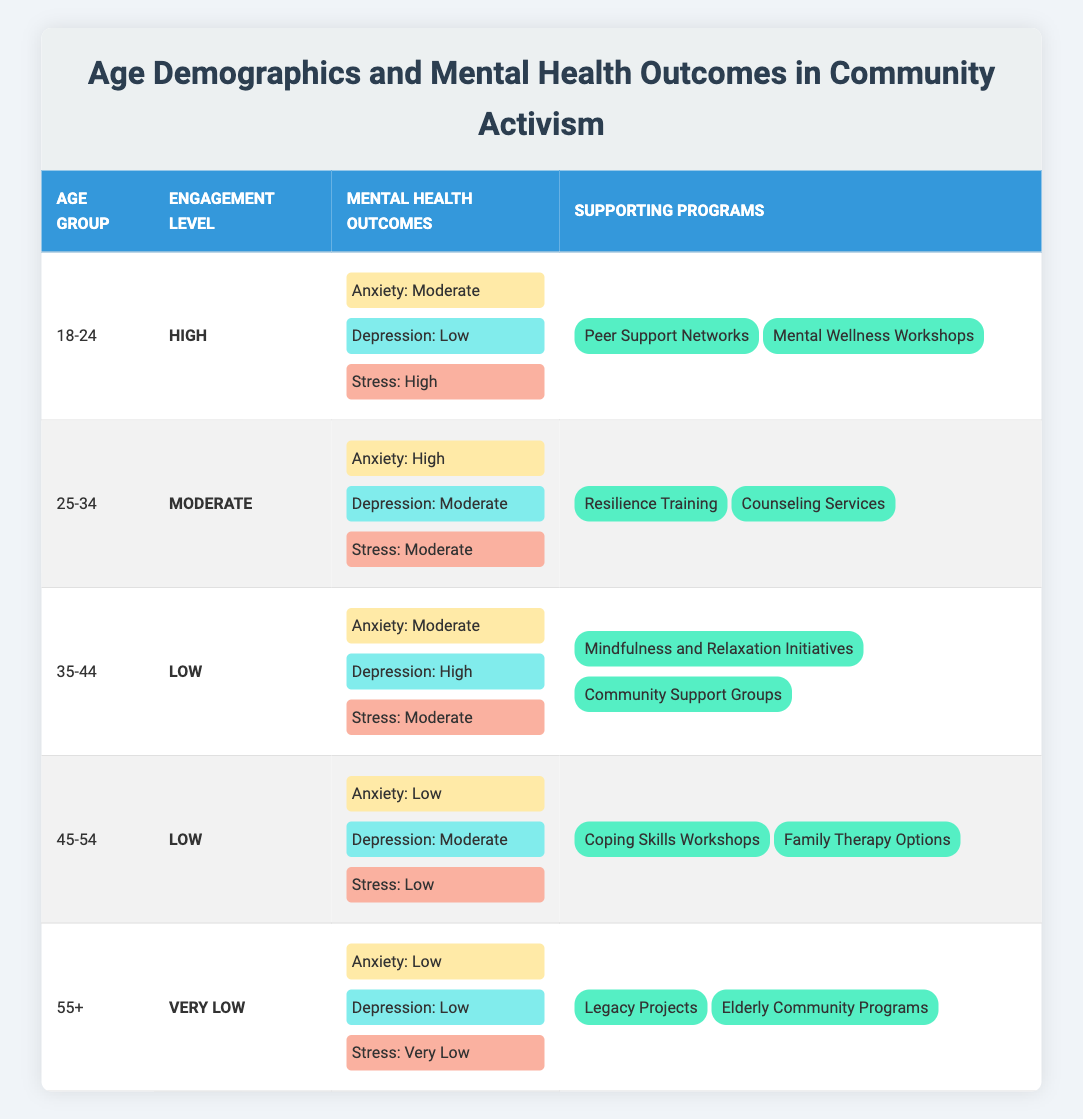What is the mental health outcome for the age group 25-34 regarding anxiety? The table indicates that for the age group 25-34, the mental health outcome for anxiety is described as "High." This information is directly taken from the corresponding row in the table.
Answer: High Which age group has the highest reported level of stress? By examining the stress levels across all age groups, the 18-24 age group is indicated to have a "High" level of stress, while others have "Moderate" or lower levels. Therefore, the age group 18-24 has the highest reported level of stress.
Answer: 18-24 Are there any supporting programs listed for the age group 45-54? The supporting programs for the age group 45-54, as indicated in the table, include "Coping Skills Workshops" and "Family Therapy Options." Thus, there are indeed supporting programs listed for this age group.
Answer: Yes What is the average anxiety level across all age groups listed in the table? The anxiety levels for each age group can be assigned the following numerical values: Low (1), Moderate (2), High (3). For age groups 18-24 (2), 25-34 (3), 35-44 (2), 45-54 (1), and 55+ (1), the average can be calculated as (2 + 3 + 2 + 1 + 1) / 5 = 1.8, which averages to 2 when rounded.
Answer: 2 In which age group is the level of depression considered the lowest? The table shows that the age group 18-24 has a reported depression level of "Low," which is the lowest when compared to the other age groups. The other groups report "Moderate" or "High."
Answer: 18-24 How does the engagement level correlate with mental health outcomes across age groups? Analyzing the table shows that younger age groups (18-24) experience higher engagement levels and varied mental health outcomes, with high stress but low depression. As engagement levels decrease in older age groups (25-34 to 55+), mental health outcomes generally improve in terms of anxiety and stress, but not depression for the 35-44 age group. This reflects that higher engagement does not equate to better overall mental health outcomes, particularly for stress and anxiety.
Answer: Higher engagement does not equate to better mental health outcomes What age group has a very low engagement level, and what are its mental health outcomes? The age group 55+ is indicated to have a "Very Low" engagement level. The mental health outcomes for this group are "Low" anxiety, "Low" depression, and "Very Low" stress. This information is obtained directly from the table.
Answer: 55+ Is the level of stress for the age group 35-44 moderate or high? According to the table, the level of stress for the age group 35-44 is classified as "Moderate." This is informed by looking at the corresponding row for that age group in the table.
Answer: Moderate 